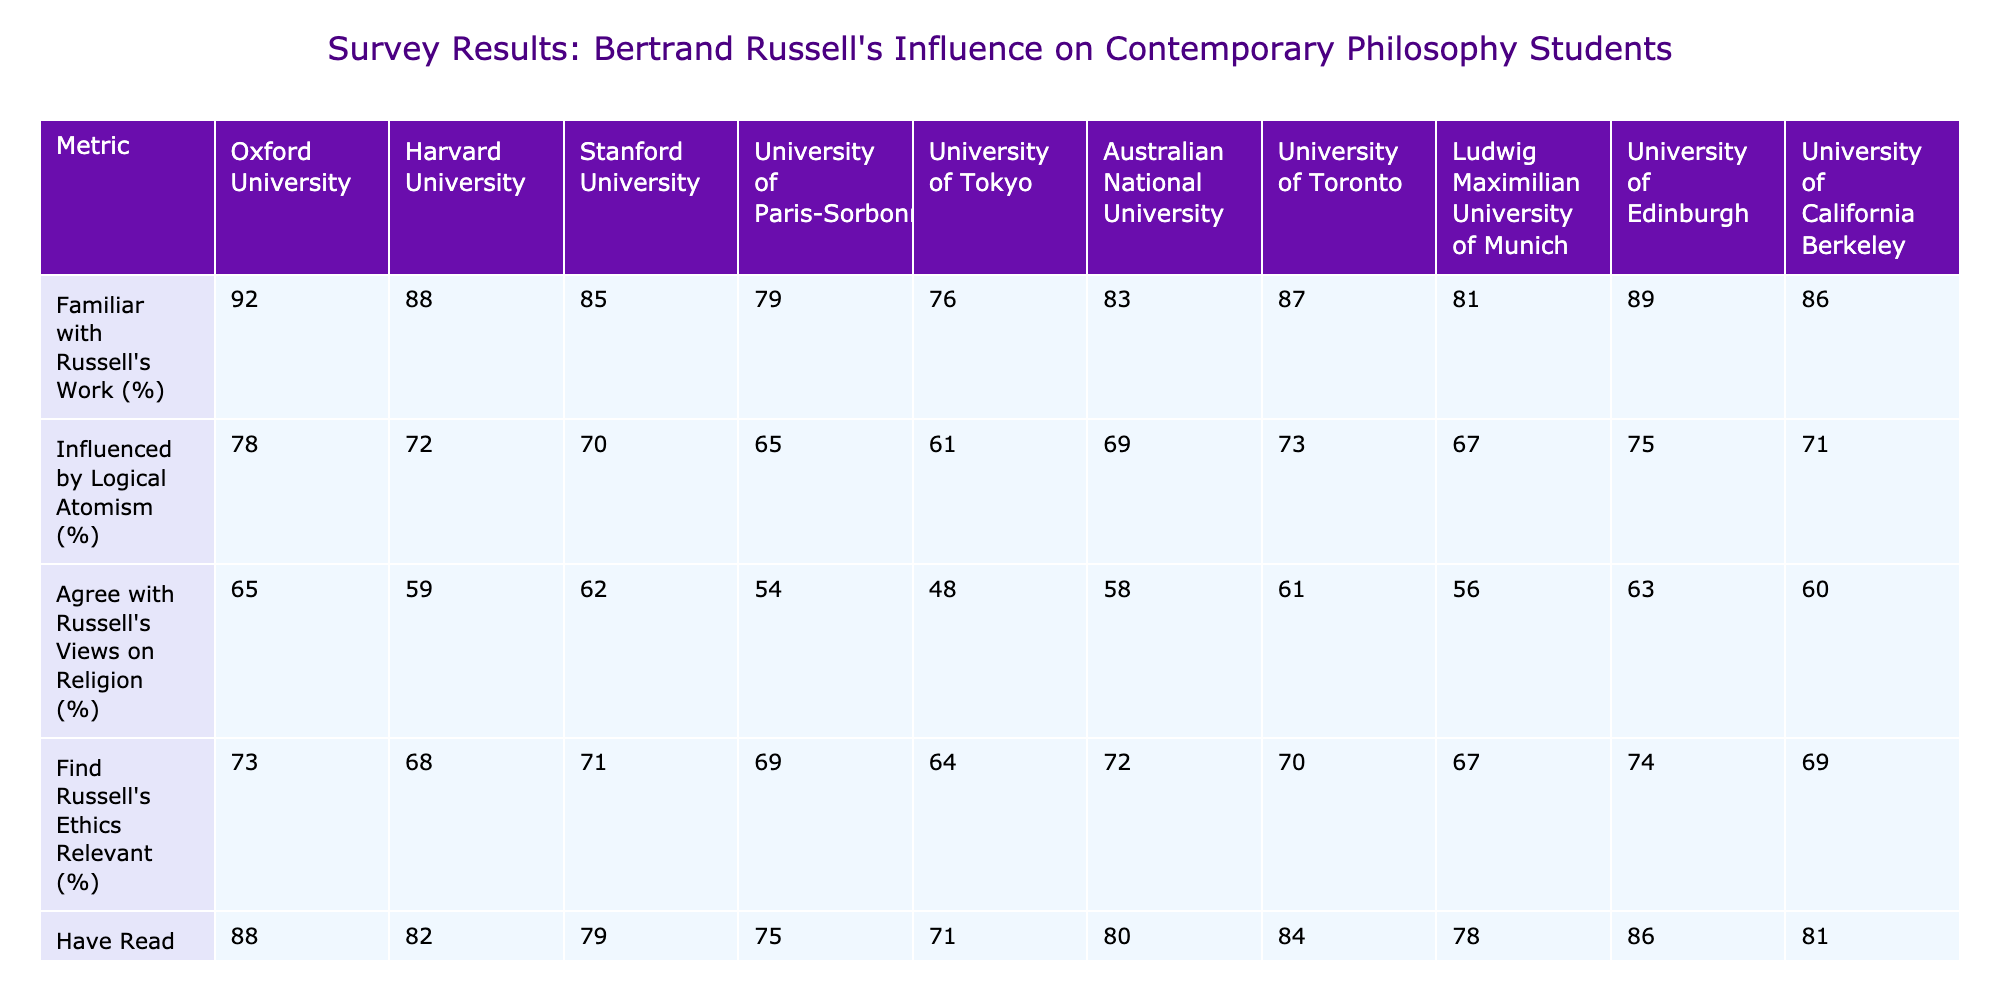What percentage of students from Harvard University are familiar with Russell's work? According to the table, Harvard University has a value of 88% for students familiar with Russell's work.
Answer: 88% Which university has the highest percentage of students who find Russell's ethics relevant? By examining the values in the "Find Russell's Ethics Relevant (%)" column, the University of Oxford has the highest value of 73%.
Answer: Oxford University What is the average percentage of students who agree with Russell's views on religion across all universities? To find the average, sum the percentages for all universities (65 + 59 + 62 + 54 + 48 + 58 + 61 + 56 + 63 + 60 =  58.4), then divide by 10 (number of universities), resulting in an average of 58.4%.
Answer: 58.4% Is it true that the University of Tokyo has more students influenced by Logical Atomism than the University of Paris-Sorbonne? The percentage of students influenced by Logical Atomism at the University of Tokyo is 61%, while at the University of Paris-Sorbonne it is 65%. Since 61% is less than 65%, the statement is false.
Answer: False What is the difference in the percentage of students who have read "The Problems of Philosophy" between the University of California Berkeley and Ludwig Maximilian University of Munich? The values for Berkeley and Munich are 81% and 78%, respectively. The difference is calculated as 81% - 78% = 3%.
Answer: 3% Which university has the lowest percentage of students who consider Russell's math contributions important? The table shows that the University of Paris-Sorbonne has the lowest percentage at 77%.
Answer: University of Paris-Sorbonne What percentage of students in Oxford University agree with Russell's views on religion? The specific value for Oxford University in the table is 65%.
Answer: 65% Are more students at the Australian National University influenced by Logical Atomism compared to the University of Toronto? The Australian National University has 69%, and the University of Toronto has 73%; thus, ANU has fewer students influenced by Logical Atomism.
Answer: False What is the median value of students who have read "The Problems of Philosophy" across all universities? To find the median, the percentages (88, 82, 79, 75, 80, 84, 86, 81, 80, and 78) need to be sorted. The middle values (79, 80) average to (79 + 80) / 2 = 79.5%.
Answer: 79.5% Which university has a higher percentage of students who find Russell's ethics relevant: Stanford University or University of Edinburgh? Stanford University shows 71%, while the University of Edinburgh shows 74%, so Edinburgh has a higher percentage.
Answer: University of Edinburgh What percentage of students from the University of Toronto have read "The Problems of Philosophy"? According to the table, the percentage is 84%.
Answer: 84% 